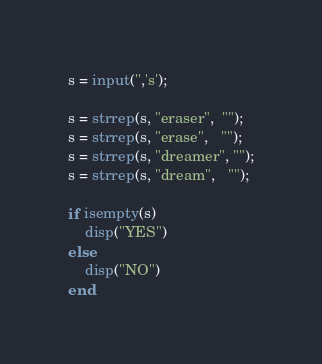Convert code to text. <code><loc_0><loc_0><loc_500><loc_500><_Octave_>s = input('','s');

s = strrep(s, "eraser",  "");
s = strrep(s, "erase",   "");
s = strrep(s, "dreamer", "");
s = strrep(s, "dream",   "");

if isempty(s)
    disp("YES")
else
    disp("NO")
end
</code> 